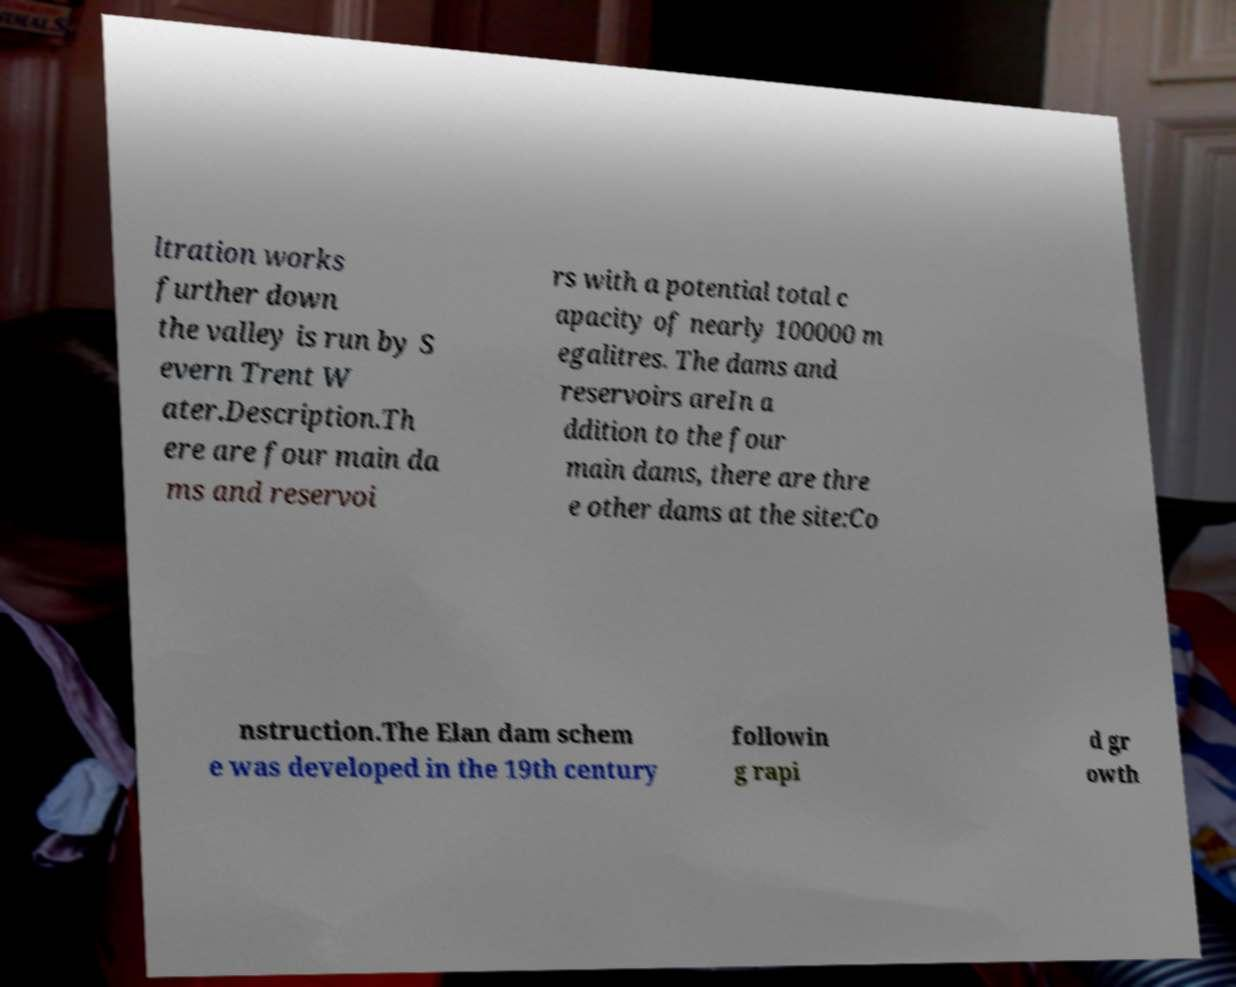Can you read and provide the text displayed in the image?This photo seems to have some interesting text. Can you extract and type it out for me? ltration works further down the valley is run by S evern Trent W ater.Description.Th ere are four main da ms and reservoi rs with a potential total c apacity of nearly 100000 m egalitres. The dams and reservoirs areIn a ddition to the four main dams, there are thre e other dams at the site:Co nstruction.The Elan dam schem e was developed in the 19th century followin g rapi d gr owth 